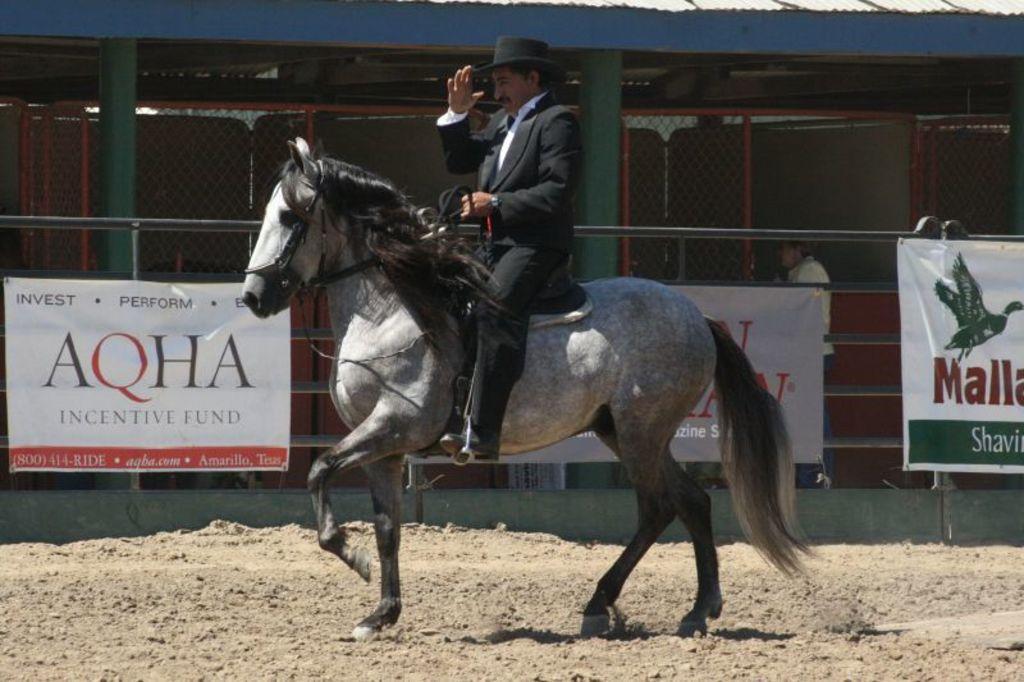In one or two sentences, can you explain what this image depicts? There is a man riding a horse. Here we can see a fence, banners, pillars, shed, and a person. 